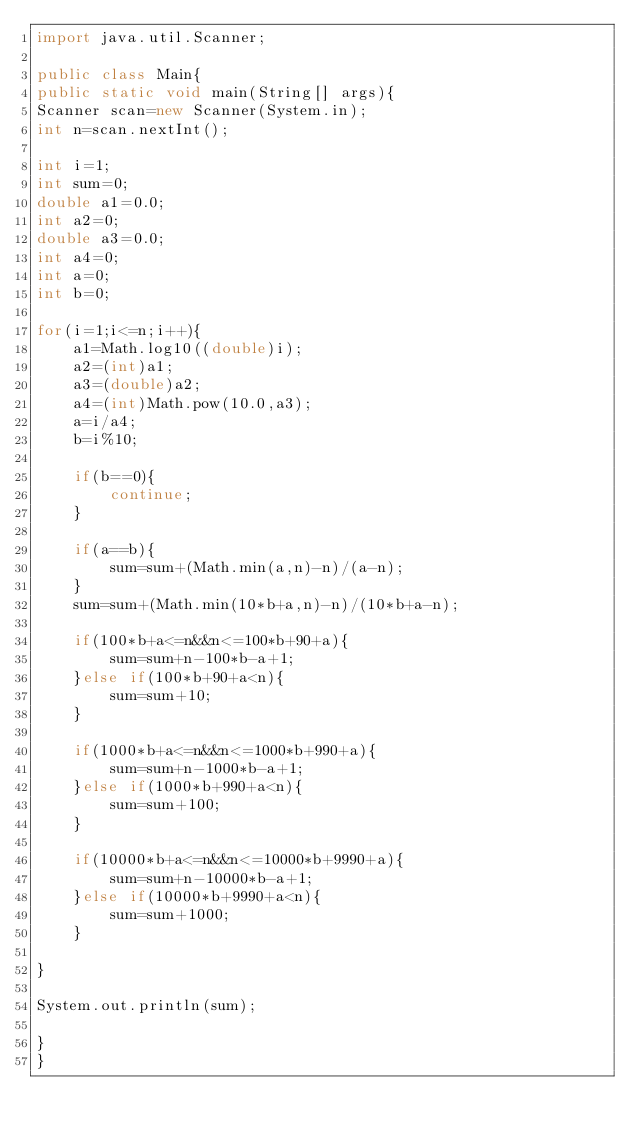Convert code to text. <code><loc_0><loc_0><loc_500><loc_500><_Java_>import java.util.Scanner;

public class Main{
public static void main(String[] args){
Scanner scan=new Scanner(System.in);
int n=scan.nextInt();

int i=1;
int sum=0;
double a1=0.0;
int a2=0;
double a3=0.0;
int a4=0;
int a=0;
int b=0;

for(i=1;i<=n;i++){
    a1=Math.log10((double)i);
    a2=(int)a1;
    a3=(double)a2;
    a4=(int)Math.pow(10.0,a3);
    a=i/a4;
    b=i%10;
  
    if(b==0){
        continue;
    }  

    if(a==b){
        sum=sum+(Math.min(a,n)-n)/(a-n);
    }
    sum=sum+(Math.min(10*b+a,n)-n)/(10*b+a-n);

    if(100*b+a<=n&&n<=100*b+90+a){
        sum=sum+n-100*b-a+1;
    }else if(100*b+90+a<n){
        sum=sum+10;
    }

    if(1000*b+a<=n&&n<=1000*b+990+a){
        sum=sum+n-1000*b-a+1;
    }else if(1000*b+990+a<n){
        sum=sum+100;
    }

    if(10000*b+a<=n&&n<=10000*b+9990+a){
        sum=sum+n-10000*b-a+1;
    }else if(10000*b+9990+a<n){
        sum=sum+1000;
    }

}

System.out.println(sum);

}
}</code> 